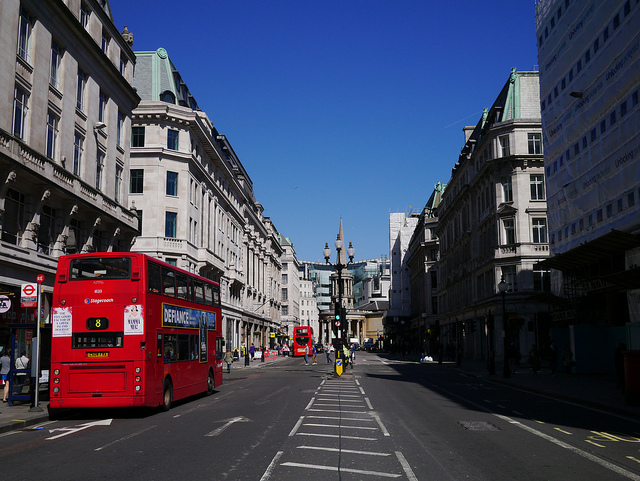How many double-decker buses are loading on the left side of the street?
A. six
B. one
C. four
D. two
Answer with the option's letter from the given choices directly. D 